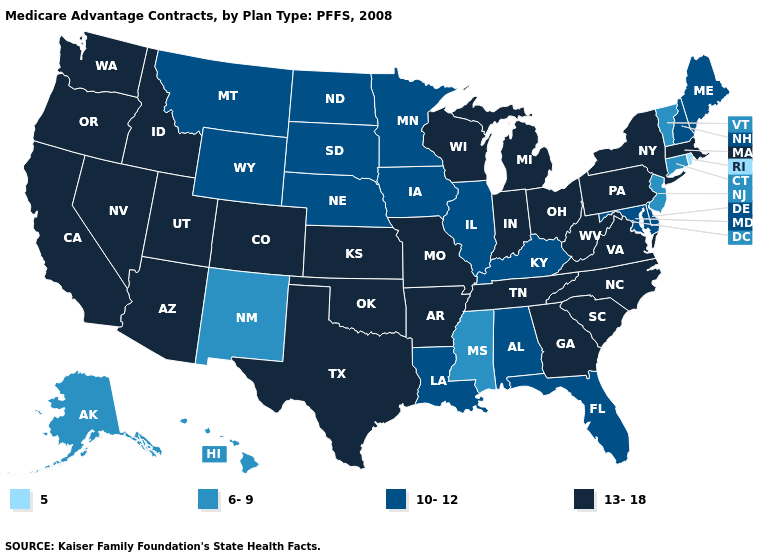What is the value of Georgia?
Write a very short answer. 13-18. What is the lowest value in the West?
Keep it brief. 6-9. What is the lowest value in states that border Montana?
Give a very brief answer. 10-12. What is the lowest value in the South?
Be succinct. 6-9. Name the states that have a value in the range 10-12?
Keep it brief. Alabama, Delaware, Florida, Iowa, Illinois, Kentucky, Louisiana, Maryland, Maine, Minnesota, Montana, North Dakota, Nebraska, New Hampshire, South Dakota, Wyoming. What is the lowest value in states that border Wyoming?
Be succinct. 10-12. What is the lowest value in the USA?
Keep it brief. 5. Does New York have a lower value than South Dakota?
Be succinct. No. Name the states that have a value in the range 13-18?
Concise answer only. Arkansas, Arizona, California, Colorado, Georgia, Idaho, Indiana, Kansas, Massachusetts, Michigan, Missouri, North Carolina, Nevada, New York, Ohio, Oklahoma, Oregon, Pennsylvania, South Carolina, Tennessee, Texas, Utah, Virginia, Washington, Wisconsin, West Virginia. What is the value of Missouri?
Be succinct. 13-18. What is the value of Pennsylvania?
Short answer required. 13-18. Does the map have missing data?
Quick response, please. No. What is the lowest value in the South?
Give a very brief answer. 6-9. Name the states that have a value in the range 13-18?
Short answer required. Arkansas, Arizona, California, Colorado, Georgia, Idaho, Indiana, Kansas, Massachusetts, Michigan, Missouri, North Carolina, Nevada, New York, Ohio, Oklahoma, Oregon, Pennsylvania, South Carolina, Tennessee, Texas, Utah, Virginia, Washington, Wisconsin, West Virginia. Name the states that have a value in the range 10-12?
Concise answer only. Alabama, Delaware, Florida, Iowa, Illinois, Kentucky, Louisiana, Maryland, Maine, Minnesota, Montana, North Dakota, Nebraska, New Hampshire, South Dakota, Wyoming. 